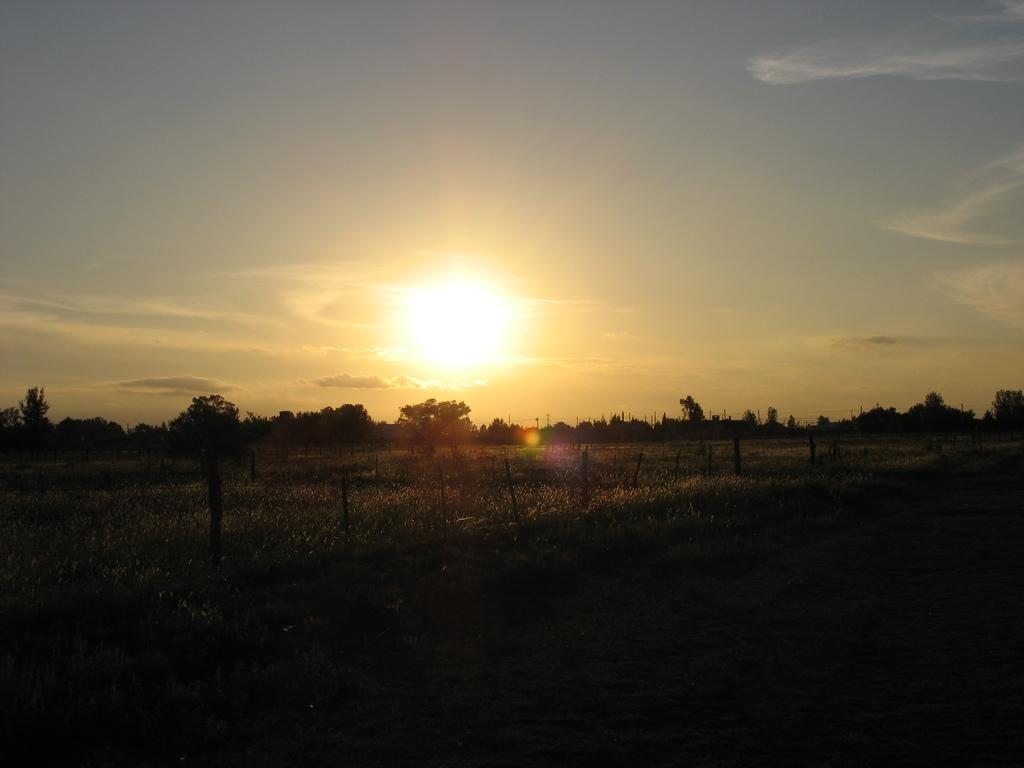Please provide a concise description of this image. In this image we can see few poles, grass, trees and the sky with clouds and the sun in the background. 